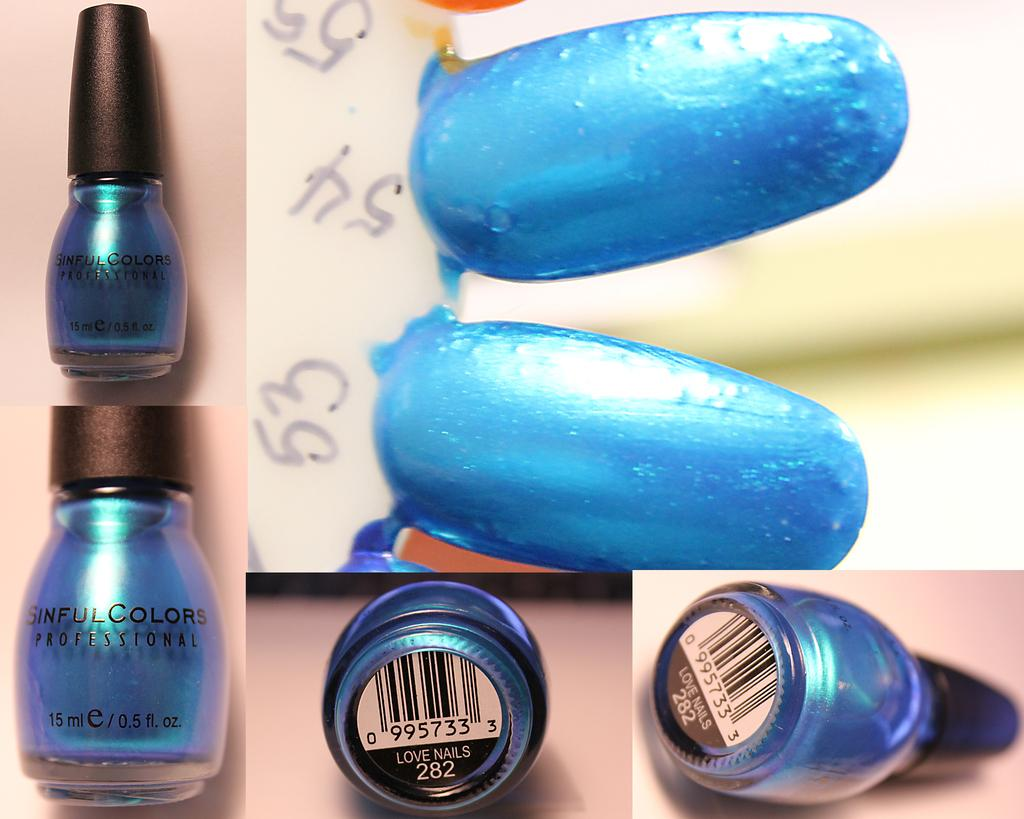<image>
Relay a brief, clear account of the picture shown. A bottle of Sinful Colors blue nail polish is sampled on fake nails. 